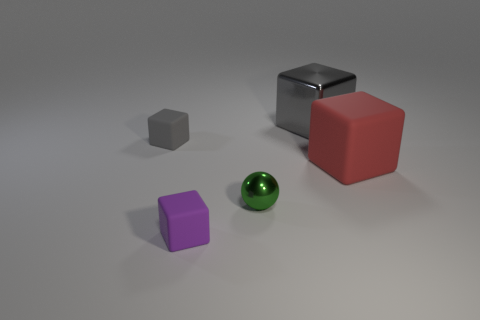Add 2 red cubes. How many objects exist? 7 Subtract all spheres. How many objects are left? 4 Add 4 small purple rubber blocks. How many small purple rubber blocks are left? 5 Add 4 purple shiny cubes. How many purple shiny cubes exist? 4 Subtract 0 brown blocks. How many objects are left? 5 Subtract all blocks. Subtract all big cyan rubber cylinders. How many objects are left? 1 